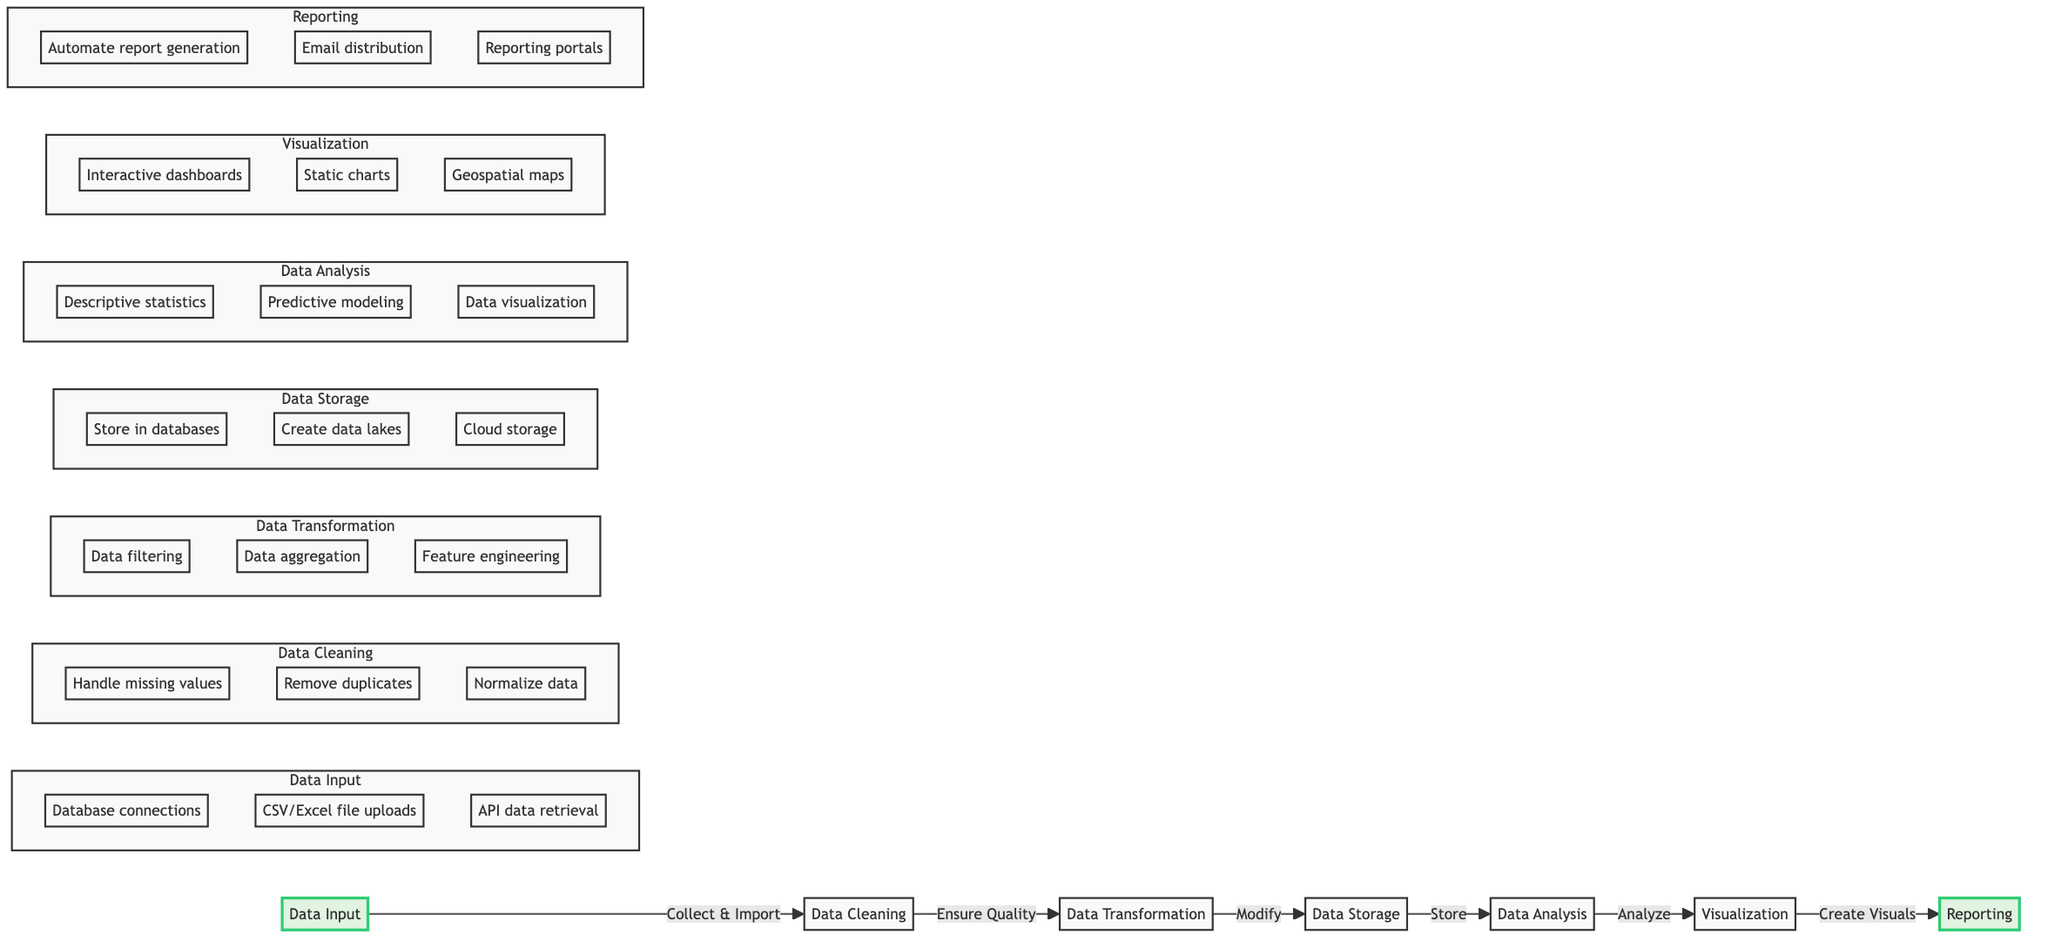What are the two main starting nodes in the diagram? The diagram begins with two main nodes: 'Data Input' and 'Reporting'. 'Data Input' is the first step, while 'Reporting' is the final output.
Answer: Data Input, Reporting How many subtasks are listed under Data Cleaning? The 'Data Cleaning' node displays three subtasks: 'Handling missing values', 'Removing duplicates', and 'Normalizing data'. Thus, it has a total of three subtasks.
Answer: Three What is the main output of the Data Analysis node? After the 'Data Analysis' phase, the primary goal is to produce insight through 'Visualization', which effectively represents the results of the analysis.
Answer: Visualization Which tool is listed under the Data Transformation node? Under 'Data Transformation', tools such as 'SQL', 'Python (NumPy, Pandas)', and 'Apache Spark' are mentioned, with 'SQL' being one example of a tool used here.
Answer: SQL What is the direct relationship between Data Storage and Data Analysis? According to the diagram, 'Data Storage' feeds into 'Data Analysis', indicating that data is stored first before analysis is conducted. This direct link showcases the workflow progression.
Answer: Store -> Analyze How many tools are listed for Reporting? In the 'Reporting' node, three different tools are identified: 'Jupyter Notebook', 'R Markdown', and 'Microsoft SharePoint'. Therefore, there are three tools assigned for Reporting.
Answer: Three Which node comes after Data Cleaning? Immediately following 'Data Cleaning' in the diagram is 'Data Transformation', indicating a sequential flow where cleaned data is then modified for analysis.
Answer: Data Transformation Which subtask involves ensuring consistency in data? The subtask 'Remove duplicates' falls under 'Data Cleaning', explicitly focused on maintaining data consistency by eliminating duplicate records.
Answer: Remove duplicates What is the purpose of the Visualization node? The 'Visualization' node serves to create various visual representations of the analysis insights, indicating its role in transforming data insights into comprehensible formats.
Answer: Create visual representations 